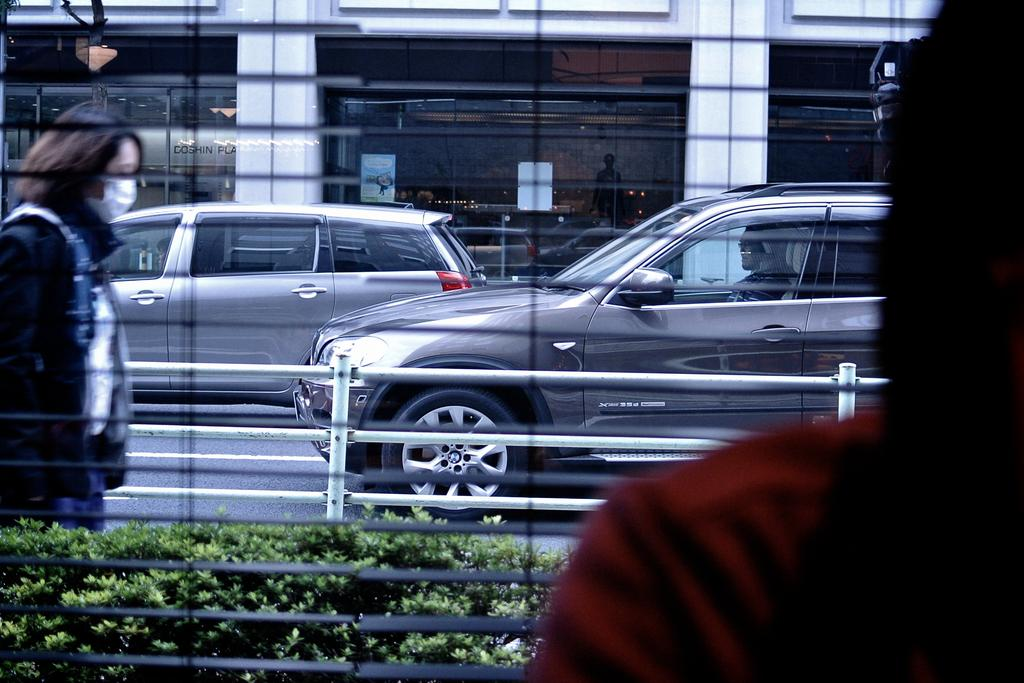What is the person in the image doing? The person is standing in front of a window. What can be seen on the road in the image? There are vehicles on the road. Is there another person visible in the image? Yes, there is a person on the road. What is visible in the background of the image? There is a building in the background. What type of mitten is the person wearing in the image? There is no mitten present in the image; the person is not wearing any gloves or mittens. 